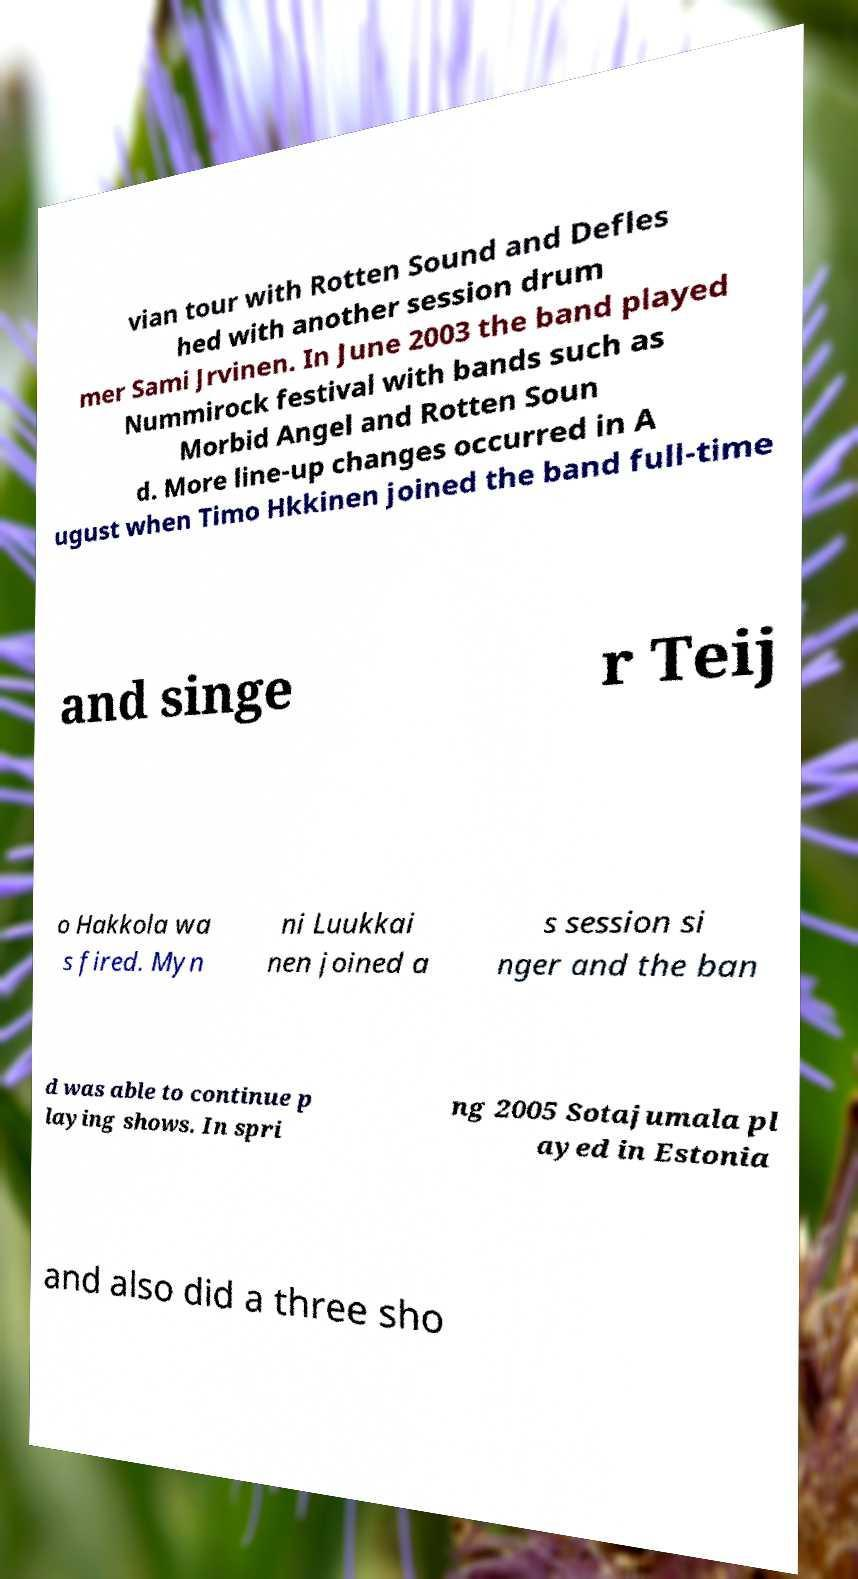Can you accurately transcribe the text from the provided image for me? vian tour with Rotten Sound and Defles hed with another session drum mer Sami Jrvinen. In June 2003 the band played Nummirock festival with bands such as Morbid Angel and Rotten Soun d. More line-up changes occurred in A ugust when Timo Hkkinen joined the band full-time and singe r Teij o Hakkola wa s fired. Myn ni Luukkai nen joined a s session si nger and the ban d was able to continue p laying shows. In spri ng 2005 Sotajumala pl ayed in Estonia and also did a three sho 